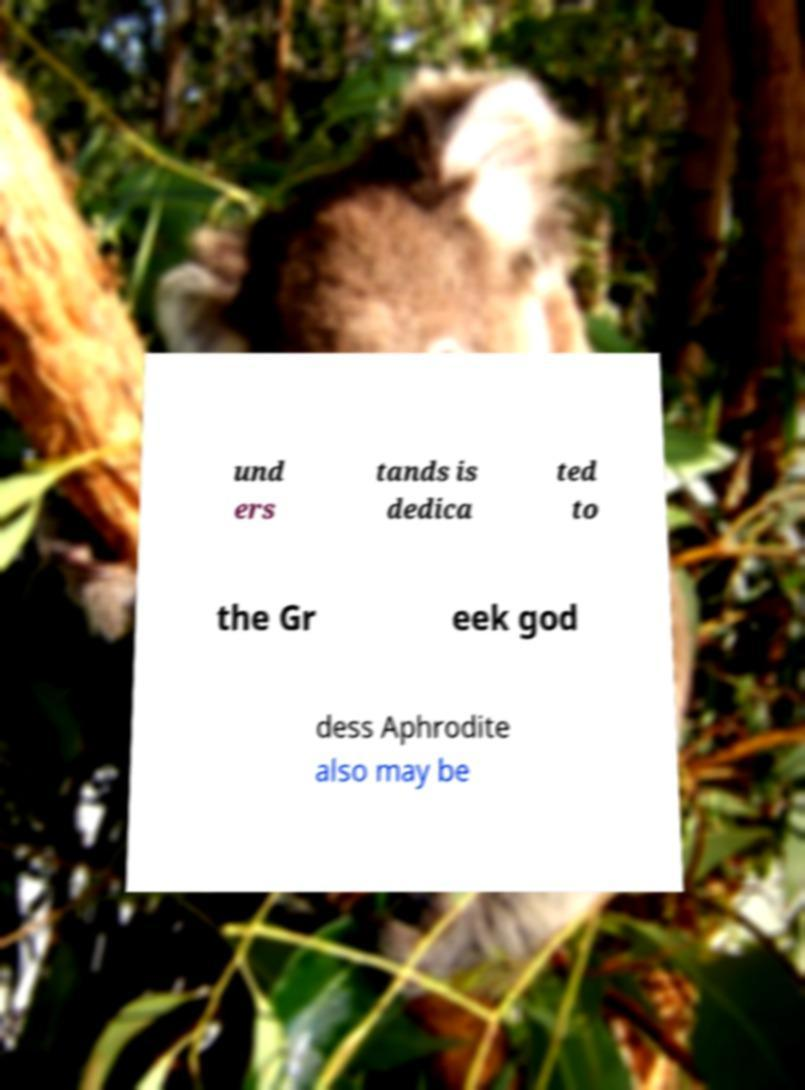Can you accurately transcribe the text from the provided image for me? und ers tands is dedica ted to the Gr eek god dess Aphrodite also may be 